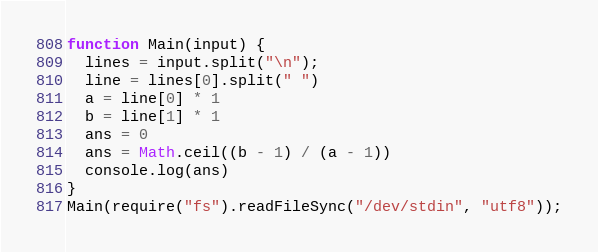Convert code to text. <code><loc_0><loc_0><loc_500><loc_500><_JavaScript_>function Main(input) {
  lines = input.split("\n");
  line = lines[0].split(" ")
  a = line[0] * 1
  b = line[1] * 1
  ans = 0
  ans = Math.ceil((b - 1) / (a - 1)) 
  console.log(ans)
}
Main(require("fs").readFileSync("/dev/stdin", "utf8"));
</code> 